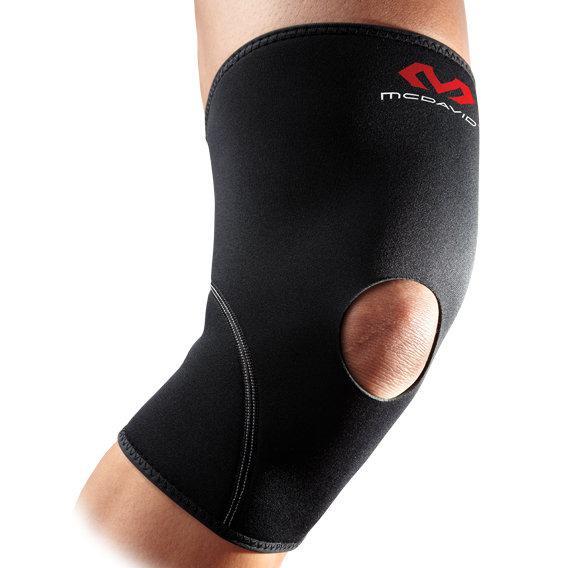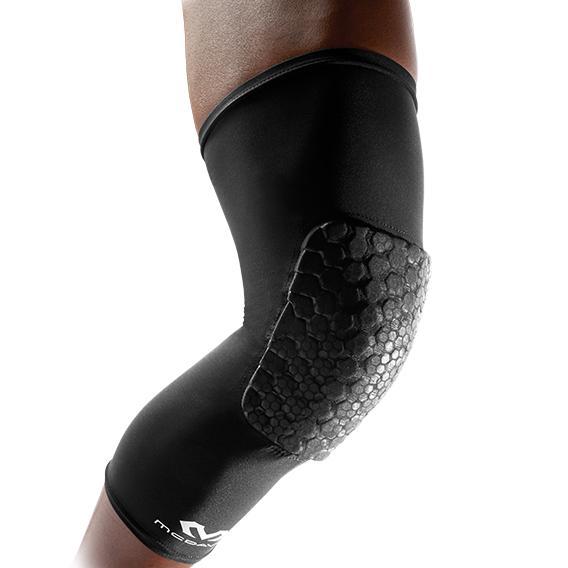The first image is the image on the left, the second image is the image on the right. For the images displayed, is the sentence "There are exactly two knee braces." factually correct? Answer yes or no. Yes. The first image is the image on the left, the second image is the image on the right. Examine the images to the left and right. Is the description "Exactly two kneepads are modeled on human legs, both of the pads black with a logo, but different designs." accurate? Answer yes or no. Yes. 